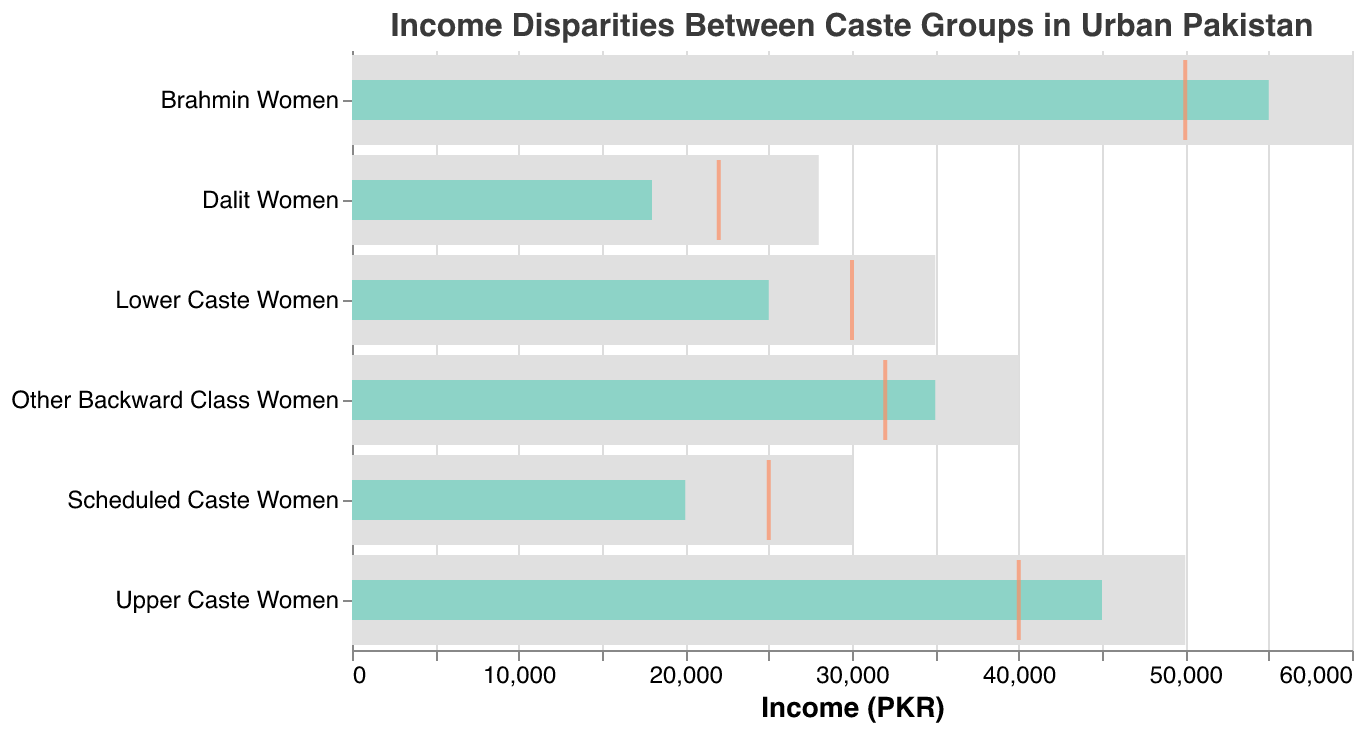What is the title of the plot? The title is displayed at the top of the plot and provides a summary of what the figure represents.
Answer: Income Disparities Between Caste Groups in Urban Pakistan How many categories are displayed in the chart? Count the number of unique data points in the Category field.
Answer: Six What color represents the actual income of each group? The actual income bars are colored differently than the background and comparison tick marks.
Answer: Light turquoise (similar to #8dd3c7) Which caste group has the highest actual income? Look at the actual income bars and identify the highest one.
Answer: Brahmin Women Which group has the smallest gap between their actual income and their target income? Calculate the difference between the actual income and target income for each group and find the smallest difference.
Answer: Other Backward Class Women (5000 PKR) Is the comparative income of Lower Caste Women higher or lower than their actual income? Compare the position of the tick mark (comparative) to the end of the bar (actual).
Answer: Higher How does the actual income of Upper Caste Women compare to that of Scheduled Caste Women? Look at the length of the actual income bars for both categories.
Answer: Upper Caste Women's actual income is higher by 25000 PKR Which group has an actual income lower than their comparative income but higher than their target income? Compare actual income (bar) with both comparative income (tick) and target income (bar background) for each group.
Answer: None What is the difference between the highest actual income and the lowest actual income? Identify the highest actual income and the lowest actual income, then subtract the latter from the former.
Answer: 55000 - 18000 = 37000 PKR Which category has the most significant disparity between their comparative income and actual income? Calculate the absolute difference between the comparative income and actual income for each group, then find the highest value.
Answer: Lower Caste Women (5000 PKR) 